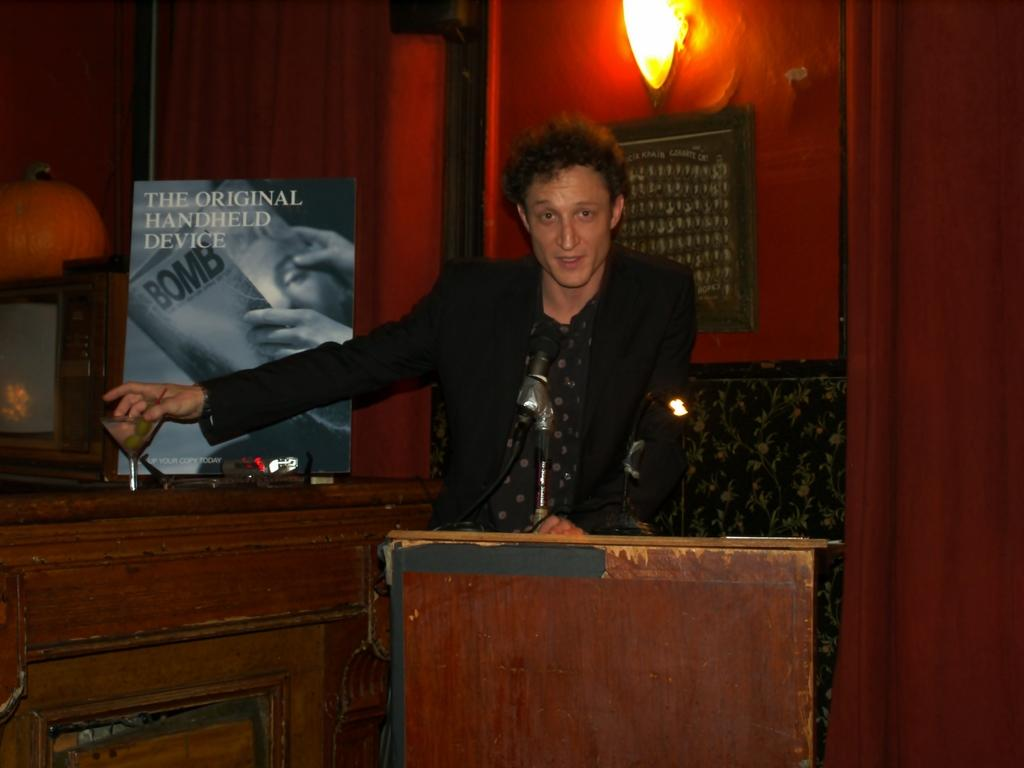Who is the main subject in the image? There is a man in the image. What is the man doing in the image? The man is standing in front of a podium. What object can be seen near the man? There is a glass in the image. What can be seen in the background of the image? There is a wall and a light in the background of the image. What type of train can be seen passing by in the image? There is no train present in the image. What kind of trail is visible in the background of the image? There is no trail visible in the image; only a wall and a light are present in the background. 